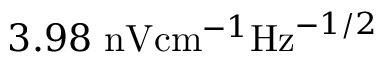<formula> <loc_0><loc_0><loc_500><loc_500>3 . 9 8 \ n V c m ^ { - 1 } H z ^ { - 1 / 2 }</formula> 